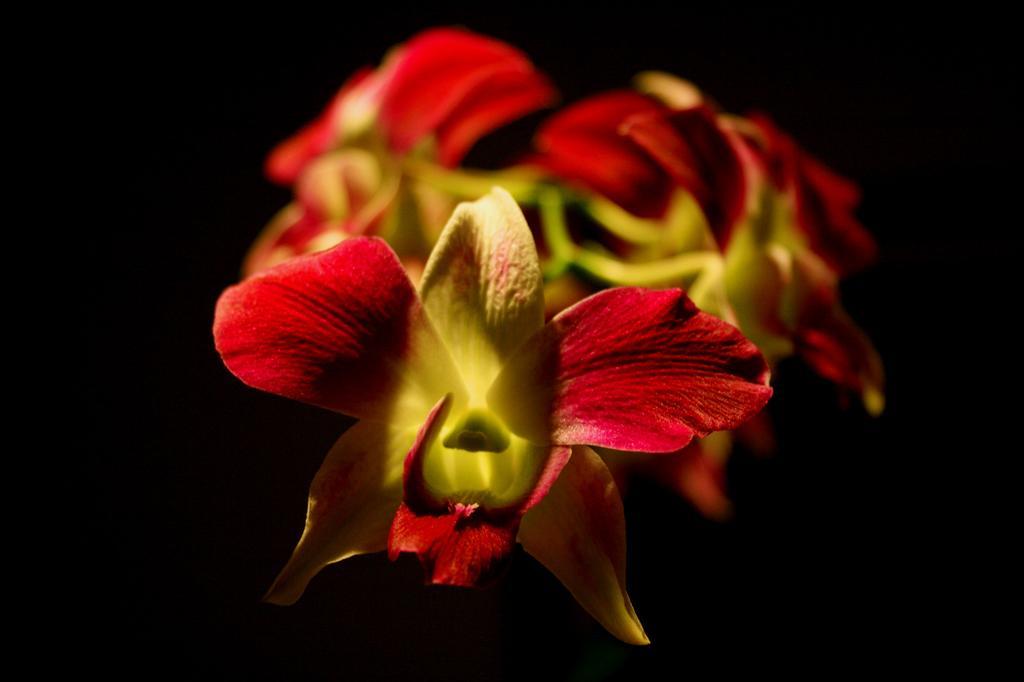In one or two sentences, can you explain what this image depicts? Here we can see a flower. In the background the image is blurry and dark but we can see flowers. 